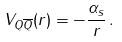Convert formula to latex. <formula><loc_0><loc_0><loc_500><loc_500>V _ { Q \overline { Q } } ( r ) = - \frac { \alpha _ { s } } { r } \, .</formula> 